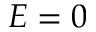Convert formula to latex. <formula><loc_0><loc_0><loc_500><loc_500>E = 0</formula> 